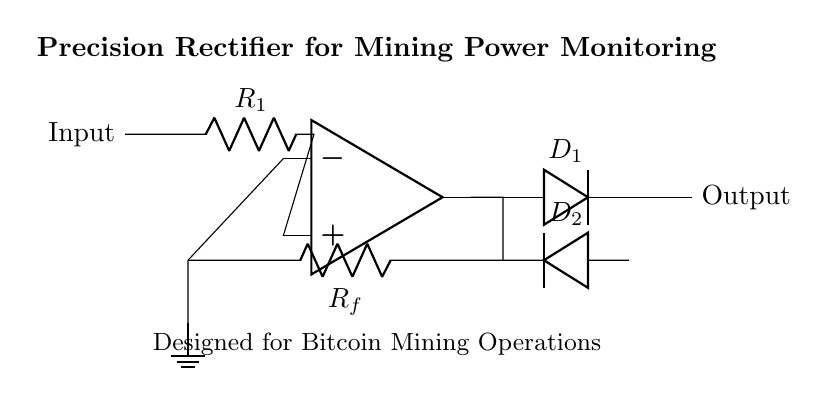What is the main purpose of this circuit? The main purpose of the circuit is to monitor power consumption in mining operations. This is indicated by the labels at the top of the circuit diagram, which specify its application for precision rectification in Bitcoin mining.
Answer: Monitor power consumption What type of diodes are used in the circuit? The circuit uses two diodes, marked as D1 and D2. The configuration shows that D2 is inverted, indicating the direction of current flow for negative cycles, typical for a precision rectifier circuit.
Answer: Two diodes What do the resistors R1 and Rf represent? Resistor R1 is the input resistor which sets the gain of the OpAmp stage, while resistor Rf is the feedback resistor that determines the feedback factor. The relationships of these resistors are crucial for controlling the rectifier's performance.
Answer: Resistors set gain and feedback How does this circuit rectify alternating current? This circuit rectifies alternating current through the use of an operational amplifier and diodes. The operational amplifier amplifies the input signal, and the diodes allow current to flow only in one direction, effectively converting alternating current to direct current.
Answer: Operational amplifier and diodes What is the output voltage of this precision rectifier? The output voltage can vary depending on the input signal and the gain set by R1 and Rf. Since it's a precision rectifier, ideally, it would follow the input voltage magnitude without dropping, especially for small signals.
Answer: Input voltage magnitude What role does the operational amplifier play in this rectifier circuit? The operational amplifier serves as an active component that improves the rectification by providing gain and controlling the precision with which the rectification is done, allowing even small input voltages to be effectively rectified.
Answer: Amplifies and controls precision What component is used to ground the circuit? The component used to ground the circuit is a ground node indicated at the end of the feedback line. It provides a reference point for the circuit, ensuring stable operation of the operational amplifier and diodes.
Answer: Ground node 